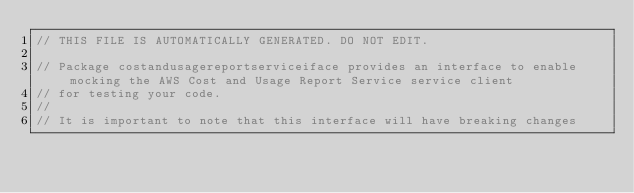Convert code to text. <code><loc_0><loc_0><loc_500><loc_500><_Go_>// THIS FILE IS AUTOMATICALLY GENERATED. DO NOT EDIT.

// Package costandusagereportserviceiface provides an interface to enable mocking the AWS Cost and Usage Report Service service client
// for testing your code.
//
// It is important to note that this interface will have breaking changes</code> 